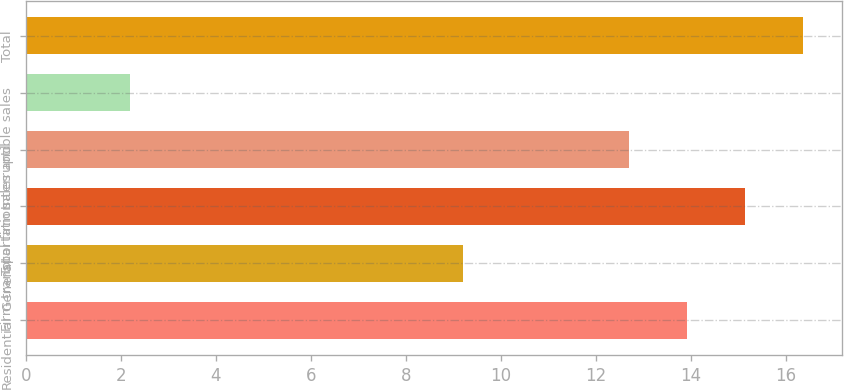<chart> <loc_0><loc_0><loc_500><loc_500><bar_chart><fcel>Residential<fcel>General<fcel>Firm transportation<fcel>Total firm sales and<fcel>Interruptible sales<fcel>Total<nl><fcel>13.92<fcel>9.2<fcel>15.14<fcel>12.7<fcel>2.2<fcel>16.36<nl></chart> 